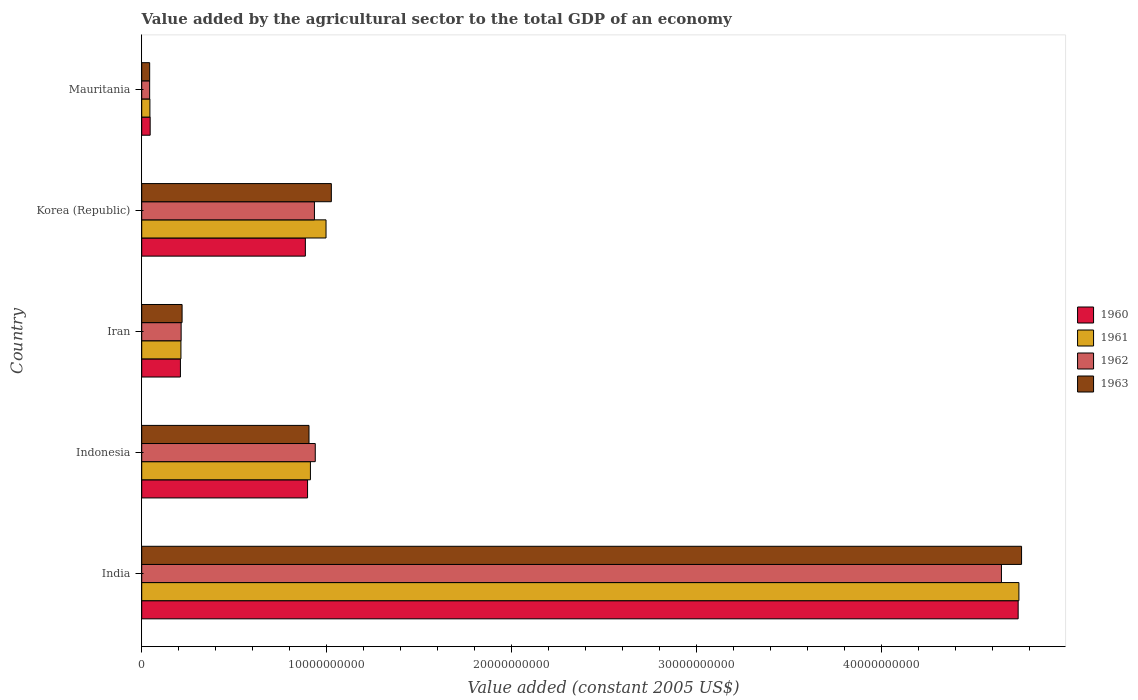How many different coloured bars are there?
Your answer should be very brief. 4. Are the number of bars per tick equal to the number of legend labels?
Ensure brevity in your answer.  Yes. How many bars are there on the 5th tick from the bottom?
Make the answer very short. 4. What is the label of the 2nd group of bars from the top?
Offer a very short reply. Korea (Republic). What is the value added by the agricultural sector in 1960 in Indonesia?
Offer a very short reply. 8.96e+09. Across all countries, what is the maximum value added by the agricultural sector in 1963?
Your answer should be very brief. 4.76e+1. Across all countries, what is the minimum value added by the agricultural sector in 1962?
Give a very brief answer. 4.29e+08. In which country was the value added by the agricultural sector in 1961 minimum?
Offer a very short reply. Mauritania. What is the total value added by the agricultural sector in 1962 in the graph?
Keep it short and to the point. 6.77e+1. What is the difference between the value added by the agricultural sector in 1960 in India and that in Indonesia?
Keep it short and to the point. 3.84e+1. What is the difference between the value added by the agricultural sector in 1961 in Mauritania and the value added by the agricultural sector in 1962 in Korea (Republic)?
Your answer should be compact. -8.89e+09. What is the average value added by the agricultural sector in 1962 per country?
Provide a succinct answer. 1.35e+1. What is the difference between the value added by the agricultural sector in 1961 and value added by the agricultural sector in 1960 in Korea (Republic)?
Your response must be concise. 1.12e+09. What is the ratio of the value added by the agricultural sector in 1960 in Indonesia to that in Mauritania?
Make the answer very short. 19.63. Is the difference between the value added by the agricultural sector in 1961 in India and Indonesia greater than the difference between the value added by the agricultural sector in 1960 in India and Indonesia?
Make the answer very short. No. What is the difference between the highest and the second highest value added by the agricultural sector in 1963?
Provide a short and direct response. 3.73e+1. What is the difference between the highest and the lowest value added by the agricultural sector in 1960?
Your answer should be compact. 4.69e+1. What does the 2nd bar from the bottom in Korea (Republic) represents?
Keep it short and to the point. 1961. How many bars are there?
Provide a succinct answer. 20. Does the graph contain grids?
Provide a succinct answer. No. How are the legend labels stacked?
Offer a very short reply. Vertical. What is the title of the graph?
Your answer should be very brief. Value added by the agricultural sector to the total GDP of an economy. Does "1990" appear as one of the legend labels in the graph?
Make the answer very short. No. What is the label or title of the X-axis?
Make the answer very short. Value added (constant 2005 US$). What is the label or title of the Y-axis?
Ensure brevity in your answer.  Country. What is the Value added (constant 2005 US$) of 1960 in India?
Ensure brevity in your answer.  4.74e+1. What is the Value added (constant 2005 US$) of 1961 in India?
Provide a succinct answer. 4.74e+1. What is the Value added (constant 2005 US$) of 1962 in India?
Provide a succinct answer. 4.65e+1. What is the Value added (constant 2005 US$) of 1963 in India?
Offer a terse response. 4.76e+1. What is the Value added (constant 2005 US$) in 1960 in Indonesia?
Your answer should be very brief. 8.96e+09. What is the Value added (constant 2005 US$) in 1961 in Indonesia?
Ensure brevity in your answer.  9.12e+09. What is the Value added (constant 2005 US$) in 1962 in Indonesia?
Provide a short and direct response. 9.38e+09. What is the Value added (constant 2005 US$) in 1963 in Indonesia?
Keep it short and to the point. 9.04e+09. What is the Value added (constant 2005 US$) of 1960 in Iran?
Provide a succinct answer. 2.09e+09. What is the Value added (constant 2005 US$) of 1961 in Iran?
Give a very brief answer. 2.12e+09. What is the Value added (constant 2005 US$) in 1962 in Iran?
Provide a short and direct response. 2.13e+09. What is the Value added (constant 2005 US$) of 1963 in Iran?
Offer a very short reply. 2.18e+09. What is the Value added (constant 2005 US$) in 1960 in Korea (Republic)?
Provide a short and direct response. 8.84e+09. What is the Value added (constant 2005 US$) in 1961 in Korea (Republic)?
Offer a very short reply. 9.96e+09. What is the Value added (constant 2005 US$) of 1962 in Korea (Republic)?
Your answer should be very brief. 9.33e+09. What is the Value added (constant 2005 US$) of 1963 in Korea (Republic)?
Your answer should be compact. 1.02e+1. What is the Value added (constant 2005 US$) of 1960 in Mauritania?
Make the answer very short. 4.57e+08. What is the Value added (constant 2005 US$) of 1961 in Mauritania?
Your answer should be compact. 4.42e+08. What is the Value added (constant 2005 US$) in 1962 in Mauritania?
Offer a very short reply. 4.29e+08. What is the Value added (constant 2005 US$) in 1963 in Mauritania?
Provide a succinct answer. 4.30e+08. Across all countries, what is the maximum Value added (constant 2005 US$) in 1960?
Ensure brevity in your answer.  4.74e+1. Across all countries, what is the maximum Value added (constant 2005 US$) of 1961?
Keep it short and to the point. 4.74e+1. Across all countries, what is the maximum Value added (constant 2005 US$) of 1962?
Ensure brevity in your answer.  4.65e+1. Across all countries, what is the maximum Value added (constant 2005 US$) in 1963?
Offer a very short reply. 4.76e+1. Across all countries, what is the minimum Value added (constant 2005 US$) in 1960?
Keep it short and to the point. 4.57e+08. Across all countries, what is the minimum Value added (constant 2005 US$) in 1961?
Keep it short and to the point. 4.42e+08. Across all countries, what is the minimum Value added (constant 2005 US$) of 1962?
Your answer should be very brief. 4.29e+08. Across all countries, what is the minimum Value added (constant 2005 US$) in 1963?
Your answer should be compact. 4.30e+08. What is the total Value added (constant 2005 US$) of 1960 in the graph?
Offer a terse response. 6.77e+1. What is the total Value added (constant 2005 US$) of 1961 in the graph?
Make the answer very short. 6.90e+1. What is the total Value added (constant 2005 US$) in 1962 in the graph?
Make the answer very short. 6.77e+1. What is the total Value added (constant 2005 US$) in 1963 in the graph?
Offer a very short reply. 6.95e+1. What is the difference between the Value added (constant 2005 US$) of 1960 in India and that in Indonesia?
Give a very brief answer. 3.84e+1. What is the difference between the Value added (constant 2005 US$) of 1961 in India and that in Indonesia?
Offer a terse response. 3.83e+1. What is the difference between the Value added (constant 2005 US$) in 1962 in India and that in Indonesia?
Give a very brief answer. 3.71e+1. What is the difference between the Value added (constant 2005 US$) of 1963 in India and that in Indonesia?
Provide a succinct answer. 3.85e+1. What is the difference between the Value added (constant 2005 US$) in 1960 in India and that in Iran?
Your answer should be compact. 4.53e+1. What is the difference between the Value added (constant 2005 US$) in 1961 in India and that in Iran?
Give a very brief answer. 4.53e+1. What is the difference between the Value added (constant 2005 US$) of 1962 in India and that in Iran?
Ensure brevity in your answer.  4.43e+1. What is the difference between the Value added (constant 2005 US$) in 1963 in India and that in Iran?
Give a very brief answer. 4.54e+1. What is the difference between the Value added (constant 2005 US$) of 1960 in India and that in Korea (Republic)?
Provide a succinct answer. 3.85e+1. What is the difference between the Value added (constant 2005 US$) in 1961 in India and that in Korea (Republic)?
Provide a succinct answer. 3.74e+1. What is the difference between the Value added (constant 2005 US$) in 1962 in India and that in Korea (Republic)?
Provide a short and direct response. 3.71e+1. What is the difference between the Value added (constant 2005 US$) in 1963 in India and that in Korea (Republic)?
Make the answer very short. 3.73e+1. What is the difference between the Value added (constant 2005 US$) in 1960 in India and that in Mauritania?
Offer a very short reply. 4.69e+1. What is the difference between the Value added (constant 2005 US$) in 1961 in India and that in Mauritania?
Offer a very short reply. 4.70e+1. What is the difference between the Value added (constant 2005 US$) of 1962 in India and that in Mauritania?
Provide a succinct answer. 4.60e+1. What is the difference between the Value added (constant 2005 US$) of 1963 in India and that in Mauritania?
Ensure brevity in your answer.  4.71e+1. What is the difference between the Value added (constant 2005 US$) of 1960 in Indonesia and that in Iran?
Give a very brief answer. 6.87e+09. What is the difference between the Value added (constant 2005 US$) of 1961 in Indonesia and that in Iran?
Provide a succinct answer. 7.00e+09. What is the difference between the Value added (constant 2005 US$) of 1962 in Indonesia and that in Iran?
Make the answer very short. 7.25e+09. What is the difference between the Value added (constant 2005 US$) of 1963 in Indonesia and that in Iran?
Provide a short and direct response. 6.86e+09. What is the difference between the Value added (constant 2005 US$) in 1960 in Indonesia and that in Korea (Republic)?
Provide a short and direct response. 1.19e+08. What is the difference between the Value added (constant 2005 US$) of 1961 in Indonesia and that in Korea (Republic)?
Your answer should be compact. -8.44e+08. What is the difference between the Value added (constant 2005 US$) of 1962 in Indonesia and that in Korea (Republic)?
Offer a very short reply. 4.52e+07. What is the difference between the Value added (constant 2005 US$) of 1963 in Indonesia and that in Korea (Republic)?
Give a very brief answer. -1.21e+09. What is the difference between the Value added (constant 2005 US$) in 1960 in Indonesia and that in Mauritania?
Keep it short and to the point. 8.51e+09. What is the difference between the Value added (constant 2005 US$) in 1961 in Indonesia and that in Mauritania?
Make the answer very short. 8.68e+09. What is the difference between the Value added (constant 2005 US$) of 1962 in Indonesia and that in Mauritania?
Provide a succinct answer. 8.95e+09. What is the difference between the Value added (constant 2005 US$) in 1963 in Indonesia and that in Mauritania?
Give a very brief answer. 8.61e+09. What is the difference between the Value added (constant 2005 US$) in 1960 in Iran and that in Korea (Republic)?
Give a very brief answer. -6.75e+09. What is the difference between the Value added (constant 2005 US$) of 1961 in Iran and that in Korea (Republic)?
Ensure brevity in your answer.  -7.84e+09. What is the difference between the Value added (constant 2005 US$) of 1962 in Iran and that in Korea (Republic)?
Ensure brevity in your answer.  -7.20e+09. What is the difference between the Value added (constant 2005 US$) in 1963 in Iran and that in Korea (Republic)?
Keep it short and to the point. -8.07e+09. What is the difference between the Value added (constant 2005 US$) in 1960 in Iran and that in Mauritania?
Your response must be concise. 1.63e+09. What is the difference between the Value added (constant 2005 US$) of 1961 in Iran and that in Mauritania?
Your answer should be very brief. 1.68e+09. What is the difference between the Value added (constant 2005 US$) in 1962 in Iran and that in Mauritania?
Give a very brief answer. 1.70e+09. What is the difference between the Value added (constant 2005 US$) of 1963 in Iran and that in Mauritania?
Give a very brief answer. 1.75e+09. What is the difference between the Value added (constant 2005 US$) in 1960 in Korea (Republic) and that in Mauritania?
Your answer should be very brief. 8.39e+09. What is the difference between the Value added (constant 2005 US$) of 1961 in Korea (Republic) and that in Mauritania?
Give a very brief answer. 9.52e+09. What is the difference between the Value added (constant 2005 US$) in 1962 in Korea (Republic) and that in Mauritania?
Provide a succinct answer. 8.91e+09. What is the difference between the Value added (constant 2005 US$) in 1963 in Korea (Republic) and that in Mauritania?
Keep it short and to the point. 9.82e+09. What is the difference between the Value added (constant 2005 US$) in 1960 in India and the Value added (constant 2005 US$) in 1961 in Indonesia?
Your response must be concise. 3.83e+1. What is the difference between the Value added (constant 2005 US$) in 1960 in India and the Value added (constant 2005 US$) in 1962 in Indonesia?
Your answer should be compact. 3.80e+1. What is the difference between the Value added (constant 2005 US$) of 1960 in India and the Value added (constant 2005 US$) of 1963 in Indonesia?
Provide a succinct answer. 3.83e+1. What is the difference between the Value added (constant 2005 US$) in 1961 in India and the Value added (constant 2005 US$) in 1962 in Indonesia?
Provide a short and direct response. 3.80e+1. What is the difference between the Value added (constant 2005 US$) in 1961 in India and the Value added (constant 2005 US$) in 1963 in Indonesia?
Make the answer very short. 3.84e+1. What is the difference between the Value added (constant 2005 US$) of 1962 in India and the Value added (constant 2005 US$) of 1963 in Indonesia?
Your answer should be compact. 3.74e+1. What is the difference between the Value added (constant 2005 US$) in 1960 in India and the Value added (constant 2005 US$) in 1961 in Iran?
Provide a succinct answer. 4.52e+1. What is the difference between the Value added (constant 2005 US$) in 1960 in India and the Value added (constant 2005 US$) in 1962 in Iran?
Offer a terse response. 4.52e+1. What is the difference between the Value added (constant 2005 US$) in 1960 in India and the Value added (constant 2005 US$) in 1963 in Iran?
Keep it short and to the point. 4.52e+1. What is the difference between the Value added (constant 2005 US$) of 1961 in India and the Value added (constant 2005 US$) of 1962 in Iran?
Ensure brevity in your answer.  4.53e+1. What is the difference between the Value added (constant 2005 US$) in 1961 in India and the Value added (constant 2005 US$) in 1963 in Iran?
Provide a succinct answer. 4.52e+1. What is the difference between the Value added (constant 2005 US$) in 1962 in India and the Value added (constant 2005 US$) in 1963 in Iran?
Make the answer very short. 4.43e+1. What is the difference between the Value added (constant 2005 US$) in 1960 in India and the Value added (constant 2005 US$) in 1961 in Korea (Republic)?
Give a very brief answer. 3.74e+1. What is the difference between the Value added (constant 2005 US$) in 1960 in India and the Value added (constant 2005 US$) in 1962 in Korea (Republic)?
Provide a succinct answer. 3.80e+1. What is the difference between the Value added (constant 2005 US$) of 1960 in India and the Value added (constant 2005 US$) of 1963 in Korea (Republic)?
Your response must be concise. 3.71e+1. What is the difference between the Value added (constant 2005 US$) in 1961 in India and the Value added (constant 2005 US$) in 1962 in Korea (Republic)?
Give a very brief answer. 3.81e+1. What is the difference between the Value added (constant 2005 US$) in 1961 in India and the Value added (constant 2005 US$) in 1963 in Korea (Republic)?
Provide a short and direct response. 3.72e+1. What is the difference between the Value added (constant 2005 US$) in 1962 in India and the Value added (constant 2005 US$) in 1963 in Korea (Republic)?
Your response must be concise. 3.62e+1. What is the difference between the Value added (constant 2005 US$) in 1960 in India and the Value added (constant 2005 US$) in 1961 in Mauritania?
Offer a terse response. 4.69e+1. What is the difference between the Value added (constant 2005 US$) of 1960 in India and the Value added (constant 2005 US$) of 1962 in Mauritania?
Ensure brevity in your answer.  4.69e+1. What is the difference between the Value added (constant 2005 US$) in 1960 in India and the Value added (constant 2005 US$) in 1963 in Mauritania?
Your answer should be very brief. 4.69e+1. What is the difference between the Value added (constant 2005 US$) of 1961 in India and the Value added (constant 2005 US$) of 1962 in Mauritania?
Your answer should be very brief. 4.70e+1. What is the difference between the Value added (constant 2005 US$) in 1961 in India and the Value added (constant 2005 US$) in 1963 in Mauritania?
Make the answer very short. 4.70e+1. What is the difference between the Value added (constant 2005 US$) in 1962 in India and the Value added (constant 2005 US$) in 1963 in Mauritania?
Provide a short and direct response. 4.60e+1. What is the difference between the Value added (constant 2005 US$) in 1960 in Indonesia and the Value added (constant 2005 US$) in 1961 in Iran?
Keep it short and to the point. 6.84e+09. What is the difference between the Value added (constant 2005 US$) in 1960 in Indonesia and the Value added (constant 2005 US$) in 1962 in Iran?
Ensure brevity in your answer.  6.83e+09. What is the difference between the Value added (constant 2005 US$) of 1960 in Indonesia and the Value added (constant 2005 US$) of 1963 in Iran?
Your answer should be very brief. 6.78e+09. What is the difference between the Value added (constant 2005 US$) in 1961 in Indonesia and the Value added (constant 2005 US$) in 1962 in Iran?
Ensure brevity in your answer.  6.99e+09. What is the difference between the Value added (constant 2005 US$) of 1961 in Indonesia and the Value added (constant 2005 US$) of 1963 in Iran?
Give a very brief answer. 6.94e+09. What is the difference between the Value added (constant 2005 US$) in 1962 in Indonesia and the Value added (constant 2005 US$) in 1963 in Iran?
Your answer should be compact. 7.20e+09. What is the difference between the Value added (constant 2005 US$) of 1960 in Indonesia and the Value added (constant 2005 US$) of 1961 in Korea (Republic)?
Make the answer very short. -9.98e+08. What is the difference between the Value added (constant 2005 US$) in 1960 in Indonesia and the Value added (constant 2005 US$) in 1962 in Korea (Republic)?
Provide a short and direct response. -3.71e+08. What is the difference between the Value added (constant 2005 US$) of 1960 in Indonesia and the Value added (constant 2005 US$) of 1963 in Korea (Republic)?
Your response must be concise. -1.28e+09. What is the difference between the Value added (constant 2005 US$) in 1961 in Indonesia and the Value added (constant 2005 US$) in 1962 in Korea (Republic)?
Your answer should be compact. -2.17e+08. What is the difference between the Value added (constant 2005 US$) in 1961 in Indonesia and the Value added (constant 2005 US$) in 1963 in Korea (Republic)?
Provide a succinct answer. -1.13e+09. What is the difference between the Value added (constant 2005 US$) in 1962 in Indonesia and the Value added (constant 2005 US$) in 1963 in Korea (Republic)?
Provide a succinct answer. -8.69e+08. What is the difference between the Value added (constant 2005 US$) of 1960 in Indonesia and the Value added (constant 2005 US$) of 1961 in Mauritania?
Give a very brief answer. 8.52e+09. What is the difference between the Value added (constant 2005 US$) in 1960 in Indonesia and the Value added (constant 2005 US$) in 1962 in Mauritania?
Keep it short and to the point. 8.53e+09. What is the difference between the Value added (constant 2005 US$) in 1960 in Indonesia and the Value added (constant 2005 US$) in 1963 in Mauritania?
Offer a very short reply. 8.53e+09. What is the difference between the Value added (constant 2005 US$) of 1961 in Indonesia and the Value added (constant 2005 US$) of 1962 in Mauritania?
Offer a terse response. 8.69e+09. What is the difference between the Value added (constant 2005 US$) of 1961 in Indonesia and the Value added (constant 2005 US$) of 1963 in Mauritania?
Your answer should be very brief. 8.69e+09. What is the difference between the Value added (constant 2005 US$) of 1962 in Indonesia and the Value added (constant 2005 US$) of 1963 in Mauritania?
Ensure brevity in your answer.  8.95e+09. What is the difference between the Value added (constant 2005 US$) of 1960 in Iran and the Value added (constant 2005 US$) of 1961 in Korea (Republic)?
Offer a very short reply. -7.87e+09. What is the difference between the Value added (constant 2005 US$) of 1960 in Iran and the Value added (constant 2005 US$) of 1962 in Korea (Republic)?
Provide a short and direct response. -7.24e+09. What is the difference between the Value added (constant 2005 US$) in 1960 in Iran and the Value added (constant 2005 US$) in 1963 in Korea (Republic)?
Offer a terse response. -8.16e+09. What is the difference between the Value added (constant 2005 US$) in 1961 in Iran and the Value added (constant 2005 US$) in 1962 in Korea (Republic)?
Ensure brevity in your answer.  -7.21e+09. What is the difference between the Value added (constant 2005 US$) in 1961 in Iran and the Value added (constant 2005 US$) in 1963 in Korea (Republic)?
Ensure brevity in your answer.  -8.13e+09. What is the difference between the Value added (constant 2005 US$) of 1962 in Iran and the Value added (constant 2005 US$) of 1963 in Korea (Republic)?
Your answer should be compact. -8.12e+09. What is the difference between the Value added (constant 2005 US$) in 1960 in Iran and the Value added (constant 2005 US$) in 1961 in Mauritania?
Give a very brief answer. 1.65e+09. What is the difference between the Value added (constant 2005 US$) of 1960 in Iran and the Value added (constant 2005 US$) of 1962 in Mauritania?
Offer a very short reply. 1.66e+09. What is the difference between the Value added (constant 2005 US$) in 1960 in Iran and the Value added (constant 2005 US$) in 1963 in Mauritania?
Offer a terse response. 1.66e+09. What is the difference between the Value added (constant 2005 US$) of 1961 in Iran and the Value added (constant 2005 US$) of 1962 in Mauritania?
Ensure brevity in your answer.  1.69e+09. What is the difference between the Value added (constant 2005 US$) of 1961 in Iran and the Value added (constant 2005 US$) of 1963 in Mauritania?
Give a very brief answer. 1.69e+09. What is the difference between the Value added (constant 2005 US$) in 1962 in Iran and the Value added (constant 2005 US$) in 1963 in Mauritania?
Offer a very short reply. 1.70e+09. What is the difference between the Value added (constant 2005 US$) in 1960 in Korea (Republic) and the Value added (constant 2005 US$) in 1961 in Mauritania?
Your answer should be very brief. 8.40e+09. What is the difference between the Value added (constant 2005 US$) of 1960 in Korea (Republic) and the Value added (constant 2005 US$) of 1962 in Mauritania?
Offer a terse response. 8.41e+09. What is the difference between the Value added (constant 2005 US$) in 1960 in Korea (Republic) and the Value added (constant 2005 US$) in 1963 in Mauritania?
Your answer should be very brief. 8.41e+09. What is the difference between the Value added (constant 2005 US$) of 1961 in Korea (Republic) and the Value added (constant 2005 US$) of 1962 in Mauritania?
Keep it short and to the point. 9.53e+09. What is the difference between the Value added (constant 2005 US$) in 1961 in Korea (Republic) and the Value added (constant 2005 US$) in 1963 in Mauritania?
Provide a short and direct response. 9.53e+09. What is the difference between the Value added (constant 2005 US$) of 1962 in Korea (Republic) and the Value added (constant 2005 US$) of 1963 in Mauritania?
Offer a very short reply. 8.90e+09. What is the average Value added (constant 2005 US$) of 1960 per country?
Your answer should be compact. 1.35e+1. What is the average Value added (constant 2005 US$) of 1961 per country?
Your response must be concise. 1.38e+1. What is the average Value added (constant 2005 US$) in 1962 per country?
Provide a short and direct response. 1.35e+1. What is the average Value added (constant 2005 US$) in 1963 per country?
Make the answer very short. 1.39e+1. What is the difference between the Value added (constant 2005 US$) in 1960 and Value added (constant 2005 US$) in 1961 in India?
Your response must be concise. -3.99e+07. What is the difference between the Value added (constant 2005 US$) of 1960 and Value added (constant 2005 US$) of 1962 in India?
Give a very brief answer. 9.03e+08. What is the difference between the Value added (constant 2005 US$) of 1960 and Value added (constant 2005 US$) of 1963 in India?
Give a very brief answer. -1.84e+08. What is the difference between the Value added (constant 2005 US$) of 1961 and Value added (constant 2005 US$) of 1962 in India?
Your answer should be very brief. 9.43e+08. What is the difference between the Value added (constant 2005 US$) of 1961 and Value added (constant 2005 US$) of 1963 in India?
Make the answer very short. -1.44e+08. What is the difference between the Value added (constant 2005 US$) of 1962 and Value added (constant 2005 US$) of 1963 in India?
Give a very brief answer. -1.09e+09. What is the difference between the Value added (constant 2005 US$) of 1960 and Value added (constant 2005 US$) of 1961 in Indonesia?
Keep it short and to the point. -1.54e+08. What is the difference between the Value added (constant 2005 US$) of 1960 and Value added (constant 2005 US$) of 1962 in Indonesia?
Your response must be concise. -4.16e+08. What is the difference between the Value added (constant 2005 US$) in 1960 and Value added (constant 2005 US$) in 1963 in Indonesia?
Ensure brevity in your answer.  -7.71e+07. What is the difference between the Value added (constant 2005 US$) of 1961 and Value added (constant 2005 US$) of 1962 in Indonesia?
Keep it short and to the point. -2.62e+08. What is the difference between the Value added (constant 2005 US$) of 1961 and Value added (constant 2005 US$) of 1963 in Indonesia?
Offer a terse response. 7.71e+07. What is the difference between the Value added (constant 2005 US$) of 1962 and Value added (constant 2005 US$) of 1963 in Indonesia?
Make the answer very short. 3.39e+08. What is the difference between the Value added (constant 2005 US$) in 1960 and Value added (constant 2005 US$) in 1961 in Iran?
Provide a short and direct response. -2.84e+07. What is the difference between the Value added (constant 2005 US$) of 1960 and Value added (constant 2005 US$) of 1962 in Iran?
Give a very brief answer. -3.89e+07. What is the difference between the Value added (constant 2005 US$) in 1960 and Value added (constant 2005 US$) in 1963 in Iran?
Your answer should be very brief. -9.02e+07. What is the difference between the Value added (constant 2005 US$) in 1961 and Value added (constant 2005 US$) in 1962 in Iran?
Make the answer very short. -1.05e+07. What is the difference between the Value added (constant 2005 US$) in 1961 and Value added (constant 2005 US$) in 1963 in Iran?
Offer a terse response. -6.18e+07. What is the difference between the Value added (constant 2005 US$) in 1962 and Value added (constant 2005 US$) in 1963 in Iran?
Your answer should be compact. -5.13e+07. What is the difference between the Value added (constant 2005 US$) of 1960 and Value added (constant 2005 US$) of 1961 in Korea (Republic)?
Keep it short and to the point. -1.12e+09. What is the difference between the Value added (constant 2005 US$) in 1960 and Value added (constant 2005 US$) in 1962 in Korea (Republic)?
Provide a short and direct response. -4.90e+08. What is the difference between the Value added (constant 2005 US$) in 1960 and Value added (constant 2005 US$) in 1963 in Korea (Republic)?
Provide a succinct answer. -1.40e+09. What is the difference between the Value added (constant 2005 US$) in 1961 and Value added (constant 2005 US$) in 1962 in Korea (Republic)?
Your response must be concise. 6.27e+08. What is the difference between the Value added (constant 2005 US$) in 1961 and Value added (constant 2005 US$) in 1963 in Korea (Republic)?
Provide a short and direct response. -2.87e+08. What is the difference between the Value added (constant 2005 US$) of 1962 and Value added (constant 2005 US$) of 1963 in Korea (Republic)?
Your answer should be compact. -9.14e+08. What is the difference between the Value added (constant 2005 US$) in 1960 and Value added (constant 2005 US$) in 1961 in Mauritania?
Ensure brevity in your answer.  1.44e+07. What is the difference between the Value added (constant 2005 US$) in 1960 and Value added (constant 2005 US$) in 1962 in Mauritania?
Make the answer very short. 2.75e+07. What is the difference between the Value added (constant 2005 US$) in 1960 and Value added (constant 2005 US$) in 1963 in Mauritania?
Offer a terse response. 2.68e+07. What is the difference between the Value added (constant 2005 US$) in 1961 and Value added (constant 2005 US$) in 1962 in Mauritania?
Give a very brief answer. 1.31e+07. What is the difference between the Value added (constant 2005 US$) in 1961 and Value added (constant 2005 US$) in 1963 in Mauritania?
Offer a very short reply. 1.24e+07. What is the difference between the Value added (constant 2005 US$) in 1962 and Value added (constant 2005 US$) in 1963 in Mauritania?
Keep it short and to the point. -7.06e+05. What is the ratio of the Value added (constant 2005 US$) of 1960 in India to that in Indonesia?
Give a very brief answer. 5.28. What is the ratio of the Value added (constant 2005 US$) in 1961 in India to that in Indonesia?
Give a very brief answer. 5.2. What is the ratio of the Value added (constant 2005 US$) of 1962 in India to that in Indonesia?
Your answer should be very brief. 4.95. What is the ratio of the Value added (constant 2005 US$) in 1963 in India to that in Indonesia?
Your answer should be compact. 5.26. What is the ratio of the Value added (constant 2005 US$) in 1960 in India to that in Iran?
Your answer should be very brief. 22.65. What is the ratio of the Value added (constant 2005 US$) of 1961 in India to that in Iran?
Provide a succinct answer. 22.37. What is the ratio of the Value added (constant 2005 US$) of 1962 in India to that in Iran?
Make the answer very short. 21.81. What is the ratio of the Value added (constant 2005 US$) in 1963 in India to that in Iran?
Provide a short and direct response. 21.8. What is the ratio of the Value added (constant 2005 US$) in 1960 in India to that in Korea (Republic)?
Your answer should be compact. 5.36. What is the ratio of the Value added (constant 2005 US$) of 1961 in India to that in Korea (Republic)?
Make the answer very short. 4.76. What is the ratio of the Value added (constant 2005 US$) of 1962 in India to that in Korea (Republic)?
Your response must be concise. 4.98. What is the ratio of the Value added (constant 2005 US$) of 1963 in India to that in Korea (Republic)?
Your answer should be very brief. 4.64. What is the ratio of the Value added (constant 2005 US$) in 1960 in India to that in Mauritania?
Your answer should be very brief. 103.72. What is the ratio of the Value added (constant 2005 US$) in 1961 in India to that in Mauritania?
Your answer should be very brief. 107.19. What is the ratio of the Value added (constant 2005 US$) of 1962 in India to that in Mauritania?
Your answer should be very brief. 108.27. What is the ratio of the Value added (constant 2005 US$) in 1963 in India to that in Mauritania?
Provide a succinct answer. 110.62. What is the ratio of the Value added (constant 2005 US$) of 1960 in Indonesia to that in Iran?
Provide a short and direct response. 4.29. What is the ratio of the Value added (constant 2005 US$) of 1961 in Indonesia to that in Iran?
Your response must be concise. 4.3. What is the ratio of the Value added (constant 2005 US$) of 1962 in Indonesia to that in Iran?
Your answer should be compact. 4.4. What is the ratio of the Value added (constant 2005 US$) in 1963 in Indonesia to that in Iran?
Make the answer very short. 4.14. What is the ratio of the Value added (constant 2005 US$) in 1960 in Indonesia to that in Korea (Republic)?
Offer a very short reply. 1.01. What is the ratio of the Value added (constant 2005 US$) in 1961 in Indonesia to that in Korea (Republic)?
Your response must be concise. 0.92. What is the ratio of the Value added (constant 2005 US$) of 1963 in Indonesia to that in Korea (Republic)?
Keep it short and to the point. 0.88. What is the ratio of the Value added (constant 2005 US$) in 1960 in Indonesia to that in Mauritania?
Your response must be concise. 19.63. What is the ratio of the Value added (constant 2005 US$) in 1961 in Indonesia to that in Mauritania?
Your answer should be compact. 20.62. What is the ratio of the Value added (constant 2005 US$) in 1962 in Indonesia to that in Mauritania?
Make the answer very short. 21.86. What is the ratio of the Value added (constant 2005 US$) of 1963 in Indonesia to that in Mauritania?
Provide a succinct answer. 21.03. What is the ratio of the Value added (constant 2005 US$) in 1960 in Iran to that in Korea (Republic)?
Give a very brief answer. 0.24. What is the ratio of the Value added (constant 2005 US$) in 1961 in Iran to that in Korea (Republic)?
Give a very brief answer. 0.21. What is the ratio of the Value added (constant 2005 US$) of 1962 in Iran to that in Korea (Republic)?
Provide a succinct answer. 0.23. What is the ratio of the Value added (constant 2005 US$) in 1963 in Iran to that in Korea (Republic)?
Keep it short and to the point. 0.21. What is the ratio of the Value added (constant 2005 US$) in 1960 in Iran to that in Mauritania?
Keep it short and to the point. 4.58. What is the ratio of the Value added (constant 2005 US$) of 1961 in Iran to that in Mauritania?
Keep it short and to the point. 4.79. What is the ratio of the Value added (constant 2005 US$) in 1962 in Iran to that in Mauritania?
Keep it short and to the point. 4.96. What is the ratio of the Value added (constant 2005 US$) in 1963 in Iran to that in Mauritania?
Give a very brief answer. 5.07. What is the ratio of the Value added (constant 2005 US$) of 1960 in Korea (Republic) to that in Mauritania?
Make the answer very short. 19.37. What is the ratio of the Value added (constant 2005 US$) in 1961 in Korea (Republic) to that in Mauritania?
Provide a short and direct response. 22.52. What is the ratio of the Value added (constant 2005 US$) of 1962 in Korea (Republic) to that in Mauritania?
Make the answer very short. 21.75. What is the ratio of the Value added (constant 2005 US$) in 1963 in Korea (Republic) to that in Mauritania?
Your answer should be compact. 23.84. What is the difference between the highest and the second highest Value added (constant 2005 US$) in 1960?
Give a very brief answer. 3.84e+1. What is the difference between the highest and the second highest Value added (constant 2005 US$) of 1961?
Your answer should be very brief. 3.74e+1. What is the difference between the highest and the second highest Value added (constant 2005 US$) of 1962?
Offer a terse response. 3.71e+1. What is the difference between the highest and the second highest Value added (constant 2005 US$) in 1963?
Keep it short and to the point. 3.73e+1. What is the difference between the highest and the lowest Value added (constant 2005 US$) in 1960?
Offer a very short reply. 4.69e+1. What is the difference between the highest and the lowest Value added (constant 2005 US$) in 1961?
Provide a short and direct response. 4.70e+1. What is the difference between the highest and the lowest Value added (constant 2005 US$) of 1962?
Provide a short and direct response. 4.60e+1. What is the difference between the highest and the lowest Value added (constant 2005 US$) in 1963?
Offer a very short reply. 4.71e+1. 